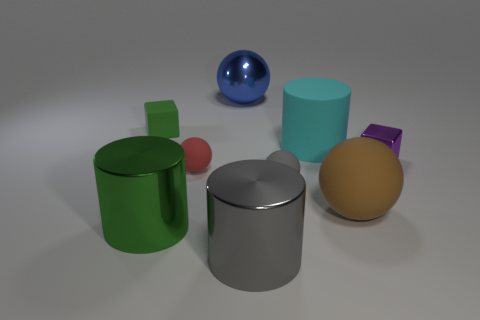What number of tiny objects are either purple blocks or red rubber objects?
Keep it short and to the point. 2. Are there more purple objects than large cubes?
Provide a succinct answer. Yes. Is the material of the green cylinder the same as the brown ball?
Your answer should be very brief. No. Are there more blue balls behind the large matte cylinder than large brown metallic balls?
Your response must be concise. Yes. How many other tiny rubber things are the same shape as the red matte object?
Offer a terse response. 1. What is the size of the green thing that is made of the same material as the red thing?
Keep it short and to the point. Small. The tiny object that is both to the left of the gray rubber ball and in front of the green block is what color?
Offer a very short reply. Red. How many purple shiny cylinders are the same size as the shiny sphere?
Give a very brief answer. 0. What is the size of the shiny cylinder that is the same color as the tiny rubber block?
Make the answer very short. Large. How big is the cylinder that is both right of the blue ball and on the left side of the cyan matte thing?
Keep it short and to the point. Large. 